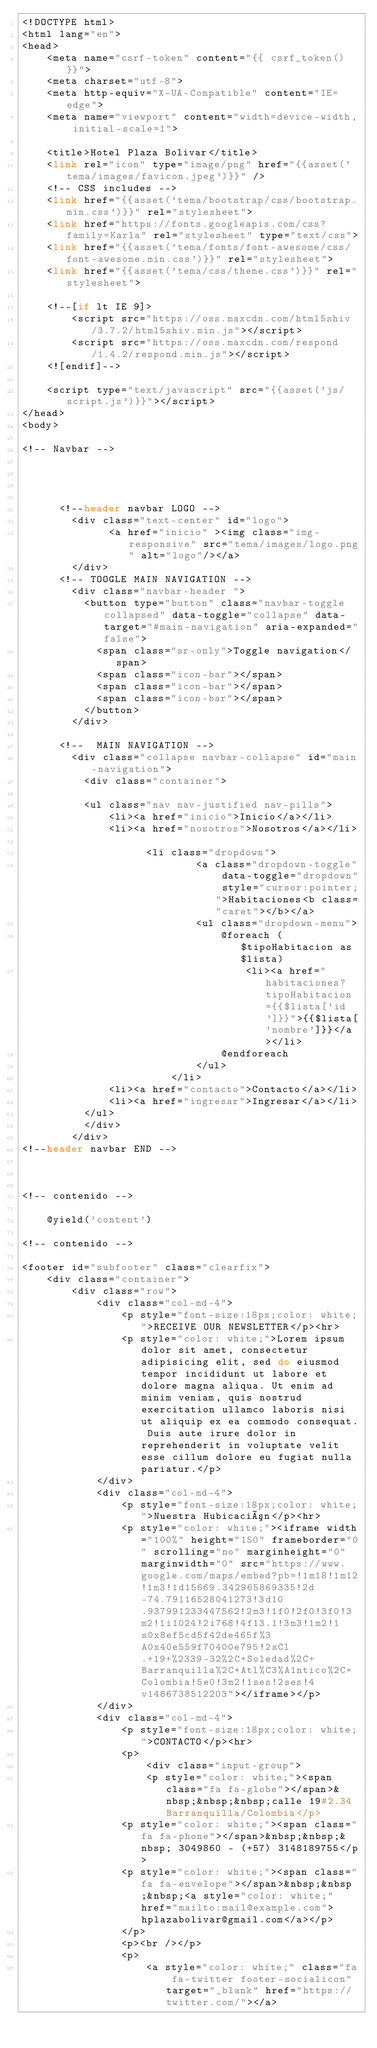<code> <loc_0><loc_0><loc_500><loc_500><_PHP_><!DOCTYPE html>
<html lang="en">
<head>
	<meta name="csrf-token" content="{{ csrf_token() }}">
	<meta charset="utf-8">
	<meta http-equiv="X-UA-Compatible" content="IE=edge">
	<meta name="viewport" content="width=device-width, initial-scale=1">

	<title>Hotel Plaza Bolivar</title>
	<link rel="icon" type="image/png" href="{{asset('tema/images/favicon.jpeg')}}" />
	<!-- CSS includes -->
	<link href="{{asset('tema/bootstrap/css/bootstrap.min.css')}}" rel="stylesheet">
	<link href="https://fonts.googleapis.com/css?family=Karla" rel="stylesheet" type="text/css">
	<link href="{{asset('tema/fonts/font-awesome/css/font-awesome.min.css')}}" rel="stylesheet">
	<link href="{{asset('tema/css/theme.css')}}" rel="stylesheet">

	<!--[if lt IE 9]>
		<script src="https://oss.maxcdn.com/html5shiv/3.7.2/html5shiv.min.js"></script>
		<script src="https://oss.maxcdn.com/respond/1.4.2/respond.min.js"></script>
	<![endif]-->

	<script type="text/javascript" src="{{asset('js/script.js')}}"></script>
</head>
<body>

<!-- Navbar -->

	

		
	  <!--header navbar LOGO -->
		<div class="text-center" id="logo">
			  <a href="inicio" ><img class="img-responsive" src="tema/images/logo.png" alt="logo"/></a>
		</div>
	  <!-- TOOGLE MAIN NAVIGATION -->
		<div class="navbar-header ">
		  <button type="button" class="navbar-toggle collapsed" data-toggle="collapse" data-target="#main-navigation" aria-expanded="false">
			<span class="sr-only">Toggle navigation</span>
			<span class="icon-bar"></span>
			<span class="icon-bar"></span>
			<span class="icon-bar"></span>
		  </button>
		</div>

	  <!--  MAIN NAVIGATION -->
		<div class="collapse navbar-collapse" id="main-navigation">
		  <div class="container">

		  <ul class="nav nav-justified nav-pills">
			  <li><a href="inicio">Inicio</a></li>
			  <li><a href="nosotros">Nosotros</a></li>
		  
					<li class="dropdown">
							<a class="dropdown-toggle" data-toggle="dropdown" style="cursor:pointer;">Habitaciones<b class="caret"></b></a>
							<ul class="dropdown-menu">
								@foreach ($tipoHabitacion as $lista)
									<li><a href="habitaciones?tipoHabitacion={{$lista['id']}}">{{$lista['nombre']}}</a></li>
								@endforeach
							</ul>
						</li>
			  <li><a href="contacto">Contacto</a></li>
			  <li><a href="ingresar">Ingresar</a></li>
		  </ul>
		  </div>
		</div>
<!--header navbar END -->



<!-- contenido -->

	@yield('content')

<!-- contenido -->

<footer id="subfooter" class="clearfix">
	<div class="container">
		<div class="row">
			<div class="col-md-4">
				<p style="font-size:18px;color: white;">RECEIVE OUR NEWSLETTER</p><hr>
				<p style="color: white;">Lorem ipsum dolor sit amet, consectetur adipisicing elit, sed do eiusmod tempor incididunt ut labore et dolore magna aliqua. Ut enim ad minim veniam, quis nostrud exercitation ullamco laboris nisi ut aliquip ex ea commodo consequat. Duis aute irure dolor in reprehenderit in voluptate velit esse cillum dolore eu fugiat nulla pariatur.</p>
			</div>
			<div class="col-md-4">
				<p style="font-size:18px;color: white;">Nuestra Hubicación</p><hr>
				<p style="color: white;"><iframe width="100%" height="150" frameborder="0" scrolling="no" marginheight="0" marginwidth="0" src="https://www.google.com/maps/embed?pb=!1m18!1m12!1m3!1d15669.342965869335!2d-74.79116528041273!3d10.937991233447562!2m3!1f0!2f0!3f0!3m2!1i1024!2i768!4f13.1!3m3!1m2!1s0x8ef5cd5f42de465f%3A0x40e559f70400e795!2sCl.+19+%2339-32%2C+Soledad%2C+Barranquilla%2C+Atl%C3%A1ntico%2C+Colombia!5e0!3m2!1ses!2ses!4v1486738512203"></iframe></p>
			</div>
			<div class="col-md-4">
				<p style="font-size:18px;color: white;">CONTACTO</p><hr>
				<p>
					<div class="input-group">
					<p style="color: white;"><span class="fa fa-globe"></span>&nbsp;&nbsp;&nbsp;calle 19#2.34 Barranquilla/Colombia</p>
				<p style="color: white;"><span class="fa fa-phone"></span>&nbsp;&nbsp;&nbsp; 3049860 - (+57) 3148189755</p>
				<p style="color: white;"><span class="fa fa-envelope"></span>&nbsp;&nbsp;&nbsp;<a style="color: white;" href="mailto:mail@example.com">hplazabolivar@gmail.com</a></p>
				</p>
				<p><br /></p>
				<p>
					<a style="color: white;" class="fa fa-twitter footer-socialicon" target="_blank" href="https://twitter.com/"></a></code> 